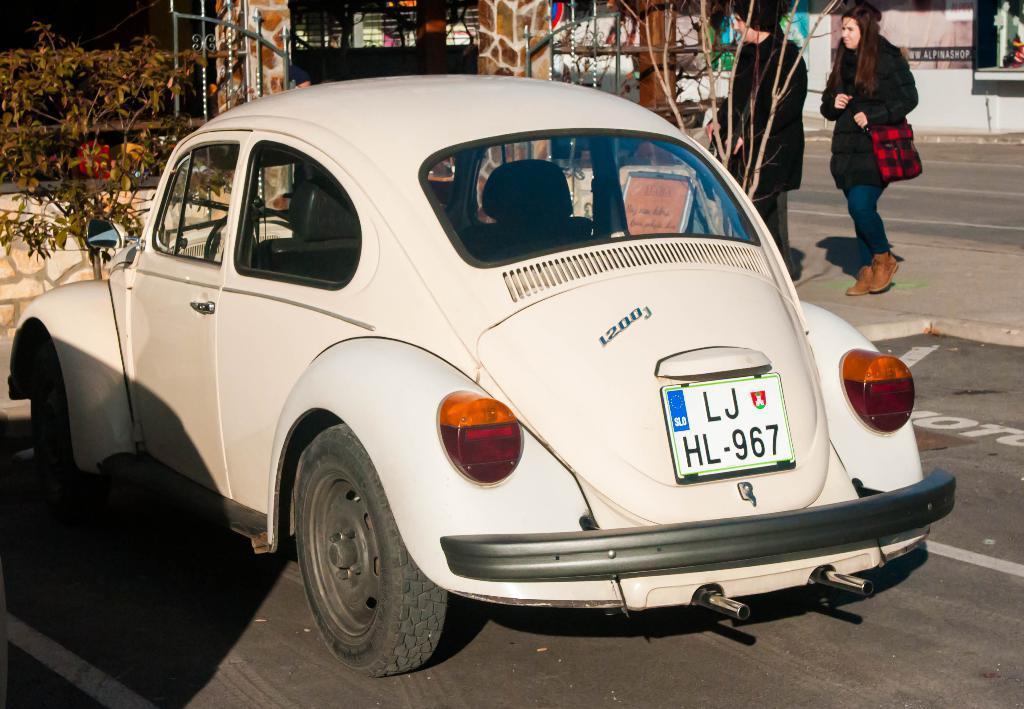Could you give a brief overview of what you see in this image? In this image I see a car which is of white in color and I see the number plate on which there are numbers and alphabets written and I see the road and I see the path on which there are 2 persons and I see few plants. In the background I see the gates. 